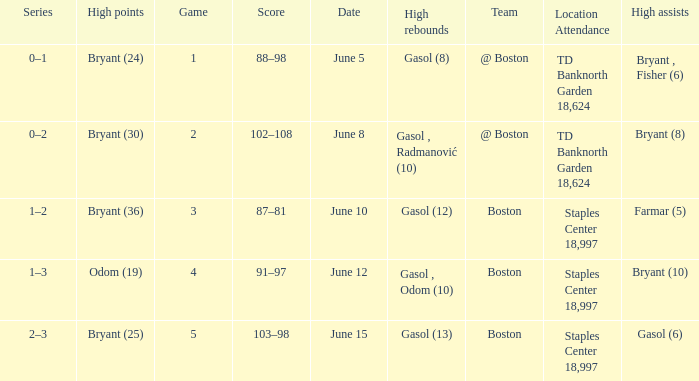Name the series on june 5 0–1. 